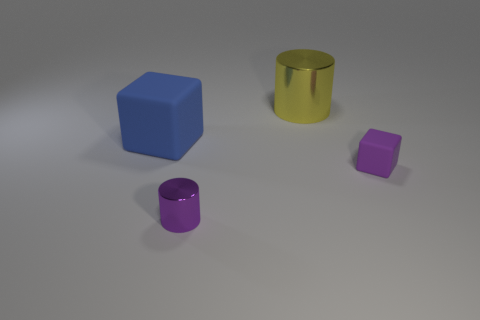Add 2 large cubes. How many objects exist? 6 Add 4 tiny purple things. How many tiny purple things are left? 6 Add 1 large blue metal cubes. How many large blue metal cubes exist? 1 Subtract 1 yellow cylinders. How many objects are left? 3 Subtract all purple cubes. Subtract all blue rubber cubes. How many objects are left? 2 